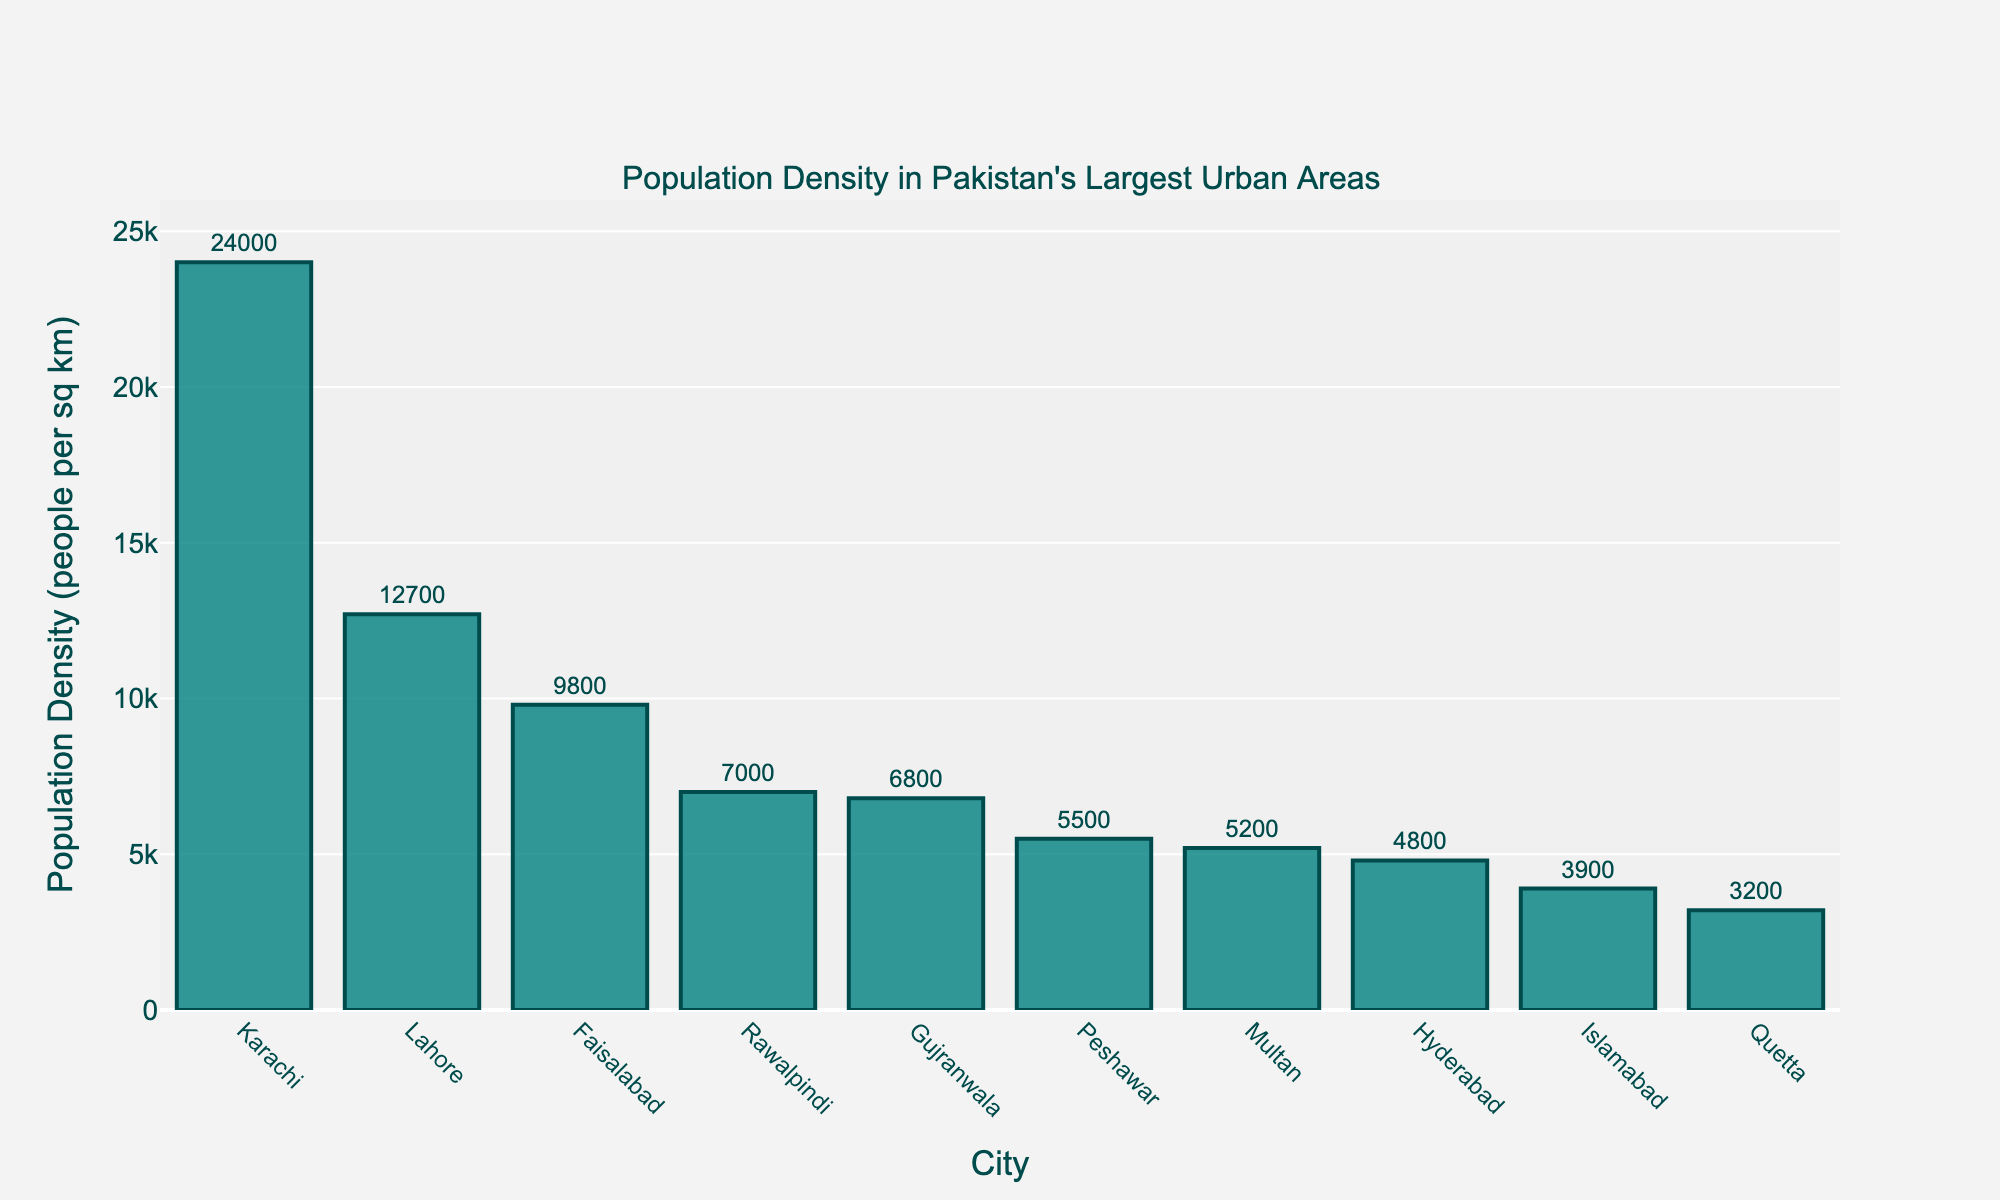Which city has the highest population density? The bar representing Karachi is the tallest and is labeled with the highest population density value of 24,000 people per sq km.
Answer: Karachi What is the population density of Lahore? The bar for Lahore is labeled with a population density value of 12,700 people per sq km.
Answer: 12,700 Compare the population densities of Faisalabad and Rawalpindi. Which city has a higher density? By observing the bars of Faisalabad and Rawalpindi, Faisalabad’s bar (9,800 people per sq km) is taller than Rawalpindi’s bar (7,000 people per sq km).
Answer: Faisalabad What is the difference in population density between Karachi and Islamabad? Karachi has a population density of 24,000 people per sq km, and Islamabad has 3,900 people per sq km. The difference is calculated as 24,000 - 3,900 = 20,100 people per sq km.
Answer: 20,100 What is the average population density of the five cities with the lowest population density? The five cities with the lowest population density, based on bar height, are Quetta (3,200), Islamabad (3,900), Hyderabad (4,800), Multan (5,200), and Peshawar (5,500). Their average density is (3200 + 3900 + 4800 + 5200 + 5500) / 5 = 22,600 / 5 = 4,520 people per sq km.
Answer: 4,520 Which city has a population density just below 10,000 people per sq km? The city with a bar just below 10,000 people per sq km is Faisalabad, with a population density of 9,800 people per sq km.
Answer: Faisalabad What is the sum of the population densities of Karachi and Lahore? Karachi's population density is 24,000 people per sq km and Lahore's is 12,700 people per sq km. Their sum is 24,000 + 12,700 = 36,700 people per sq km.
Answer: 36,700 How much greater is Karachi's population density compared to Quetta's? Karachi’s population density is 24,000 people per sq km and Quetta’s is 3,200 people per sq km. The difference is 24,000 - 3,200 = 20,800 people per sq km.
Answer: 20,800 How many cities have a population density higher than 6,000 people per sq km? By counting the bars higher than 6,000 on the y-axis, there are six cities: Karachi, Lahore, Faisalabad, Rawalpindi, Gujranwala, and Peshawar.
Answer: 6 